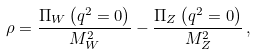<formula> <loc_0><loc_0><loc_500><loc_500>\rho = \frac { \Pi _ { W } \left ( q ^ { 2 } = 0 \right ) } { M _ { W } ^ { 2 } } - \frac { \Pi _ { Z } \left ( q ^ { 2 } = 0 \right ) } { M _ { Z } ^ { 2 } } \, ,</formula> 